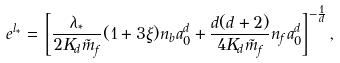Convert formula to latex. <formula><loc_0><loc_0><loc_500><loc_500>e ^ { l _ { * } } = \, \left [ \frac { \lambda _ { * } } { 2 K _ { d } \tilde { m } _ { f } } ( 1 + 3 \xi ) n _ { b } a _ { 0 } ^ { d } + \frac { d ( d + 2 ) } { 4 K _ { d } \tilde { m } _ { f } } n _ { f } a _ { 0 } ^ { d } \right ] ^ { - \frac { 1 } { d } } ,</formula> 